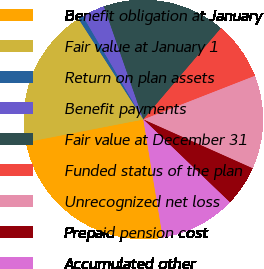Convert chart to OTSL. <chart><loc_0><loc_0><loc_500><loc_500><pie_chart><fcel>Benefit obligation at January<fcel>Fair value at January 1<fcel>Return on plan assets<fcel>Benefit payments<fcel>Fair value at December 31<fcel>Funded status of the plan<fcel>Unrecognized net loss<fcel>Prepaid pension cost<fcel>Accumulated other<nl><fcel>24.55%<fcel>18.94%<fcel>0.69%<fcel>3.08%<fcel>16.56%<fcel>7.85%<fcel>12.62%<fcel>5.47%<fcel>10.24%<nl></chart> 